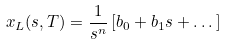Convert formula to latex. <formula><loc_0><loc_0><loc_500><loc_500>x _ { L } ( s , T ) = \frac { 1 } { s ^ { n } } \left [ b _ { 0 } + b _ { 1 } s + \dots \right ]</formula> 